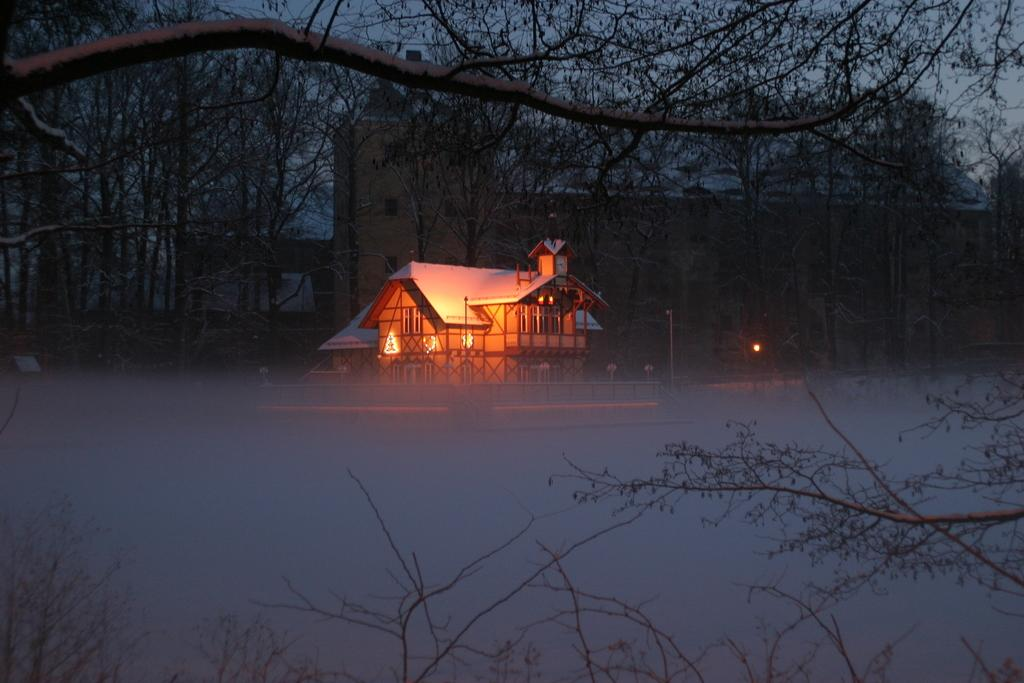What type of structure is present in the image? There is a house in the image. What features can be seen on the house? The house has windows and grills. What other natural elements are visible in the image? There are trees in the image. What artificial elements can be seen in the image? There are lights and a pole in the image. What other structures are present in the image? There are buildings in the image. What is visible in the background of the image? The sky is visible in the image. What grade does the house receive for its coughing etiquette in the image? There is no mention of coughing or grades in the image, as it features a house with windows, grills, trees, lights, a pole, and other buildings. 